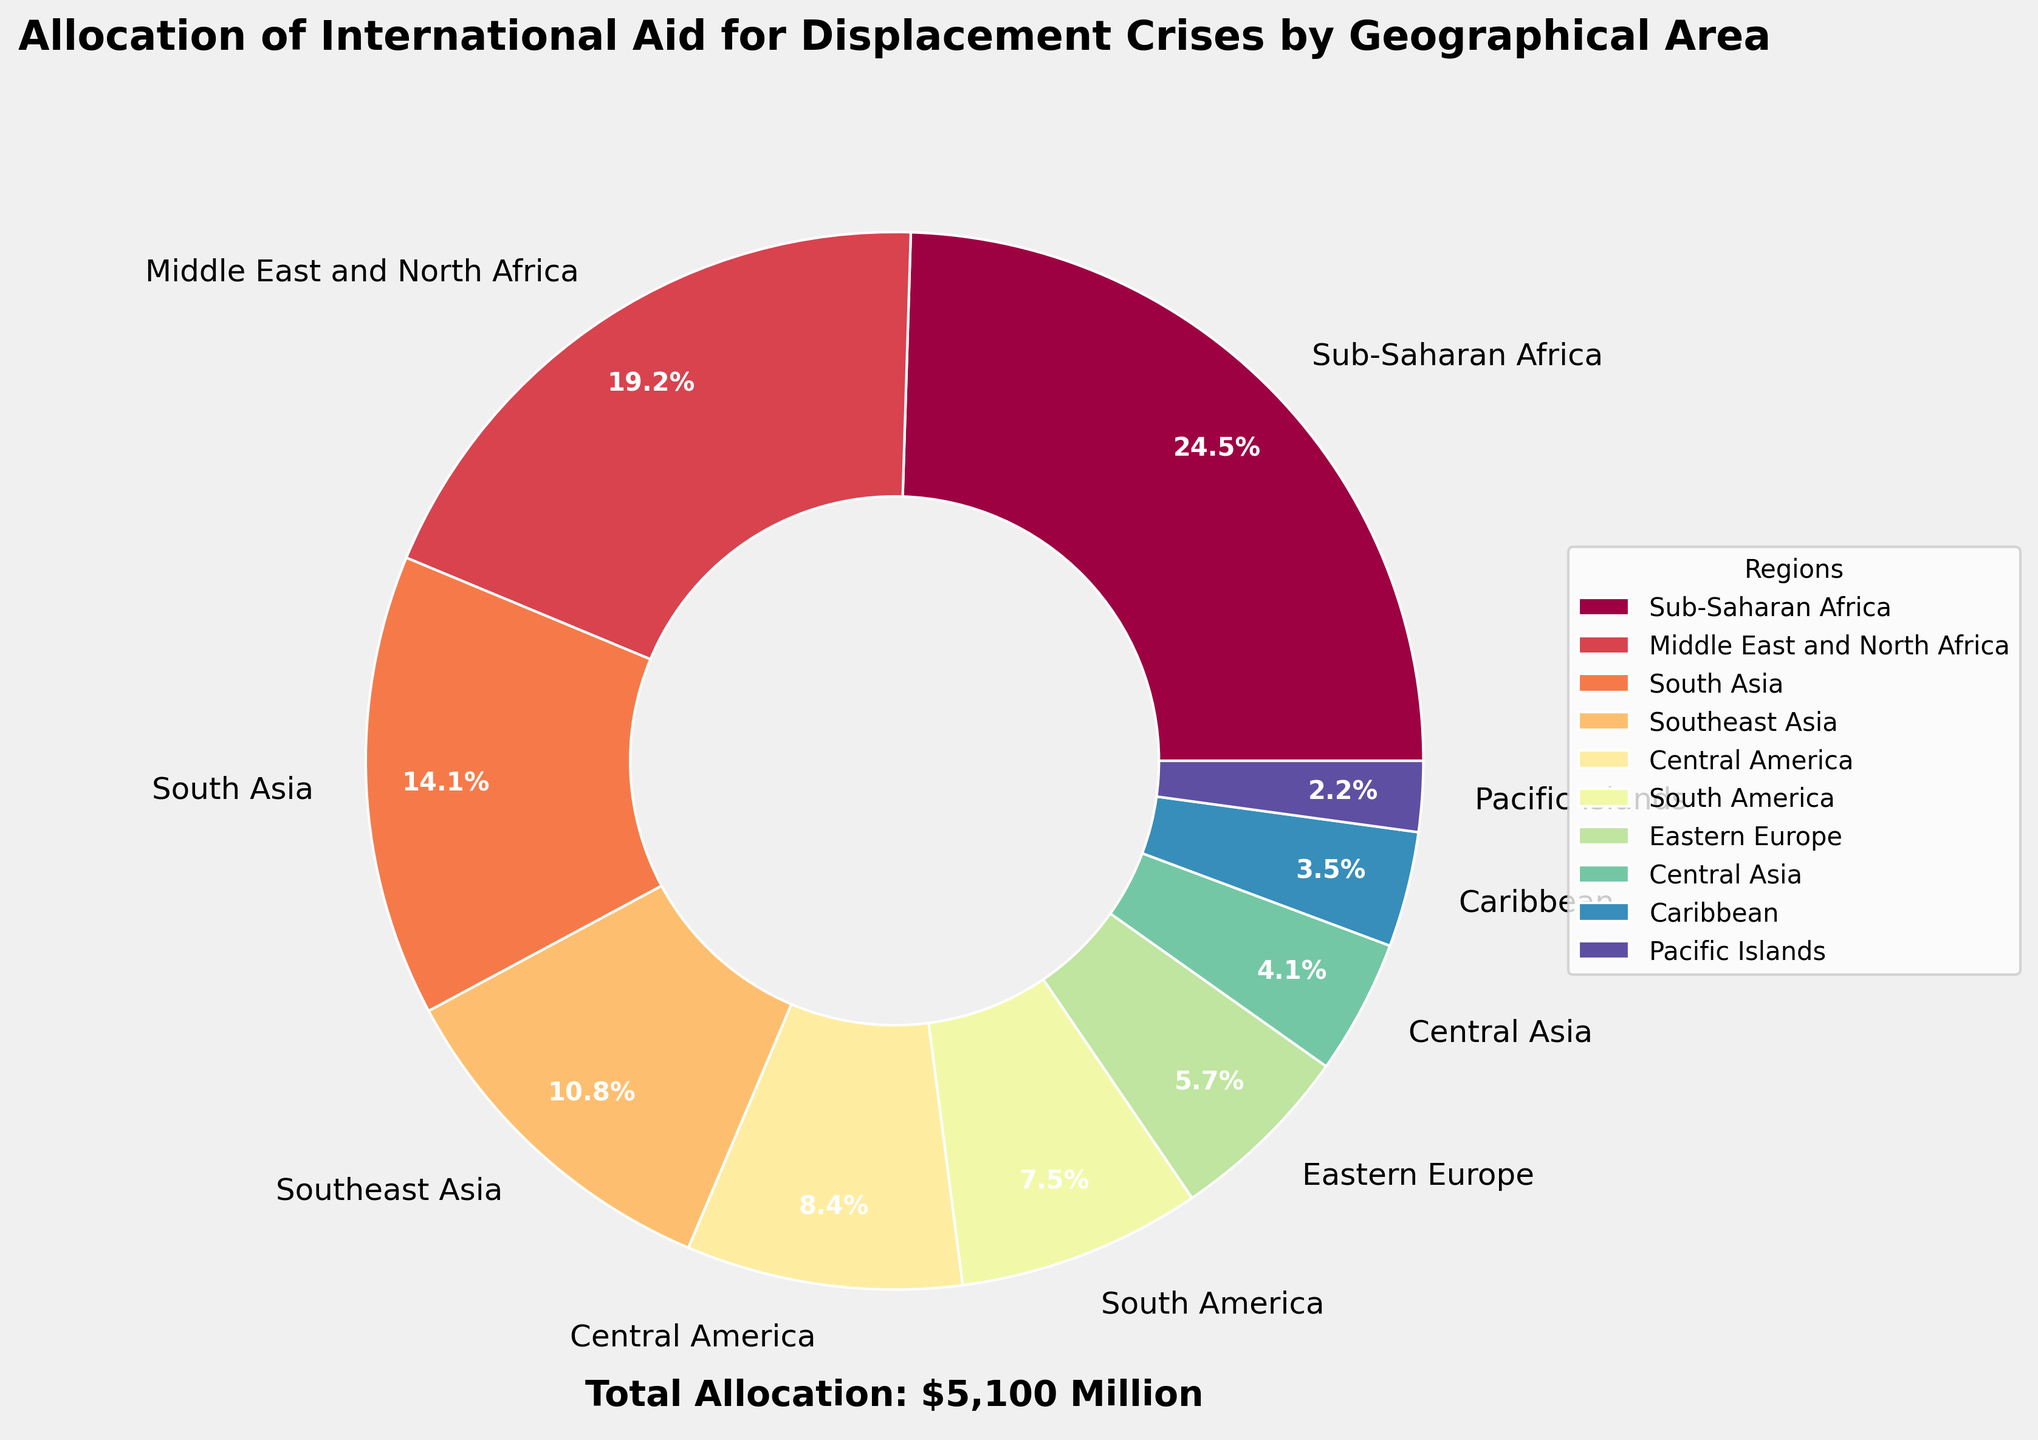Which region receives the highest allocation of aid? The largest slice of the pie chart is labeled "Sub-Saharan Africa," indicating it receives the highest allocation of international aid.
Answer: Sub-Saharan Africa What's the total combined aid allocation for Central Asia and Caribbean? The pie chart shows allocations of 210 million USD for Central Asia and 180 million USD for the Caribbean. Adding these amounts: 210 + 180 = 390 million USD.
Answer: 390 million USD Rank the top three regions by aid allocation. By examining the size of the slices and their labels, the top three regions are Sub-Saharan Africa (1250 million USD), Middle East and North Africa (980 million USD), and South Asia (720 million USD).
Answer: Sub-Saharan Africa, Middle East and North Africa, South Asia Which regions receive less than 300 million USD in aid allocation? The pie chart shows the following regions below 300 million USD: Eastern Europe (290 million USD), Central Asia (210 million USD), Caribbean (180 million USD), and Pacific Islands (110 million USD).
Answer: Eastern Europe, Central Asia, Caribbean, Pacific Islands Compare the aid allocation between Southeast Asia and South America. Which one receives more? The pie chart shows allocations of 550 million USD for Southeast Asia and 380 million USD for South America. Therefore, Southeast Asia receives more aid.
Answer: Southeast Asia What percentage of the total international aid does Sub-Saharan Africa receive? Sub-Saharan Africa has an aid allocation of 1250 million USD. The total allocation (given on the chart) sums to 5100 million USD. Calculating the percentage: (1250 / 5100) * 100 ≈ 24.5%.
Answer: 24.5% Is there a region that receives almost half the aid compared to Middle East and North Africa? If so, which one? Middle East and North Africa has an aid allocation of 980 million USD. About half of that is approximately 490 million USD. The given regions with close amounts are Southeast Asia (550 million USD) and Central America (430 million USD). Both are close, but Central America is closer.
Answer: Central America Identify the region with the smallest allocation and state the amount. The smallest slice on the pie chart is labeled "Pacific Islands," receiving 110 million USD in aid.
Answer: Pacific Islands, 110 million USD What is the combined percentage of total aid allocated to South Asia and Central America? South Asia has an allocation of 720 million USD, and Central America has 430 million USD. The total allocation is 5100 million USD. Their combined percentage is ((720 + 430) / 5100) * 100 ≈ 22.6%.
Answer: 22.6% 